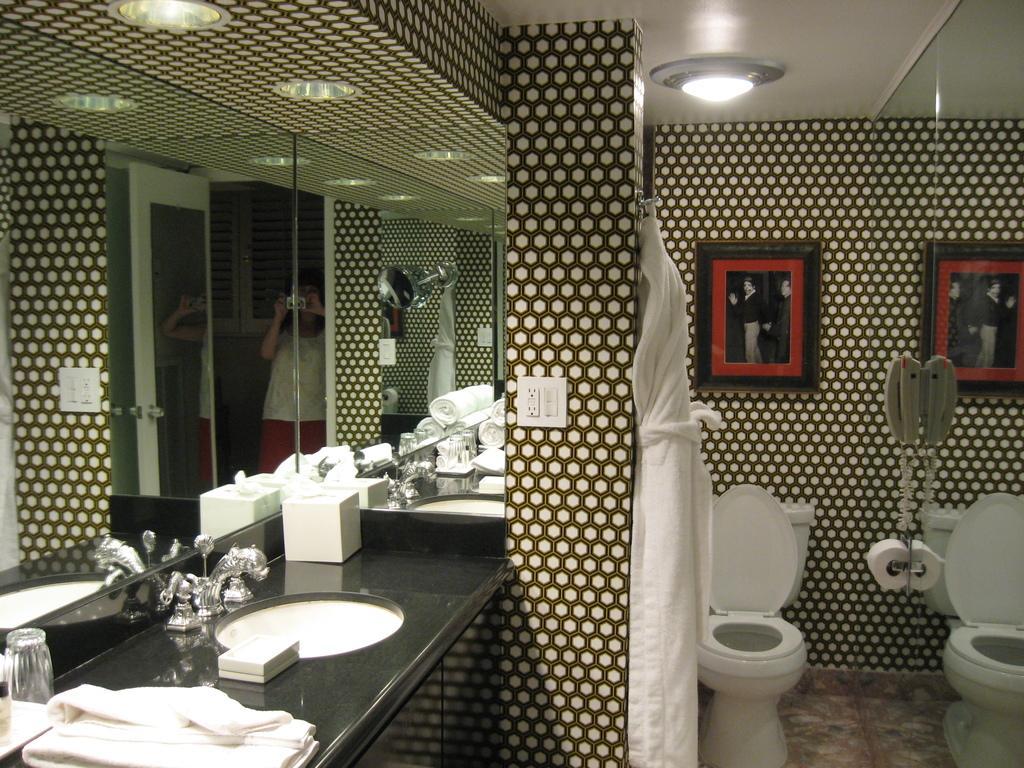Describe this image in one or two sentences. This image is taken in the bathroom and here we can see a toilet, sink, some clothes and a jar are placed on the counter table. There is a mirror and through the mirror, we can see a lady holding camera in her hands. In the background, we can see lights and a frame placed on the wall. 